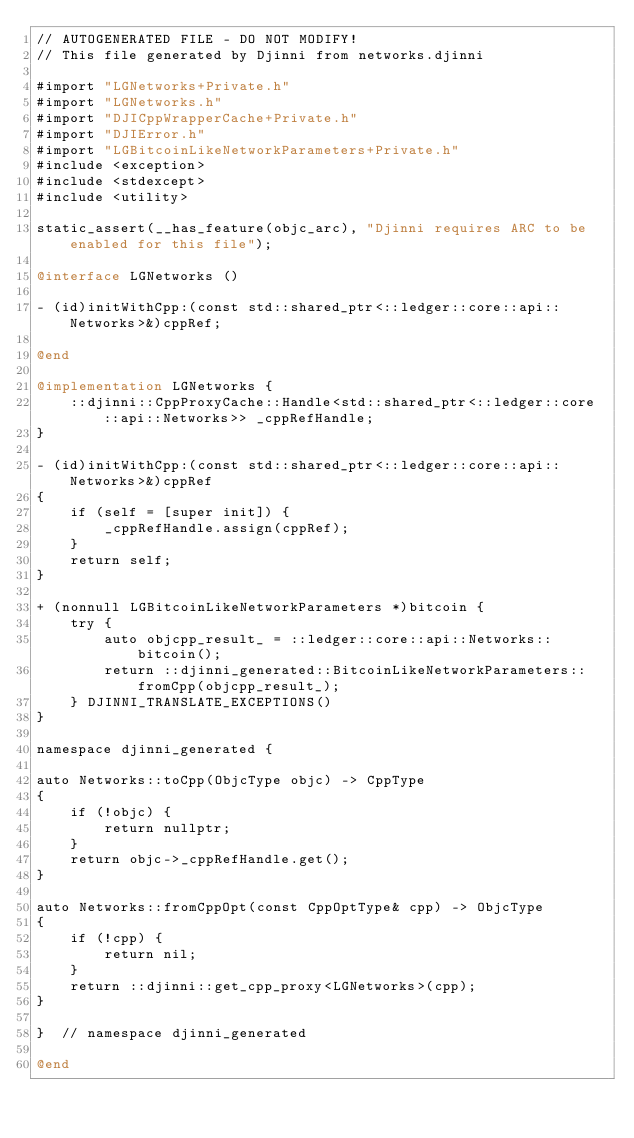<code> <loc_0><loc_0><loc_500><loc_500><_ObjectiveC_>// AUTOGENERATED FILE - DO NOT MODIFY!
// This file generated by Djinni from networks.djinni

#import "LGNetworks+Private.h"
#import "LGNetworks.h"
#import "DJICppWrapperCache+Private.h"
#import "DJIError.h"
#import "LGBitcoinLikeNetworkParameters+Private.h"
#include <exception>
#include <stdexcept>
#include <utility>

static_assert(__has_feature(objc_arc), "Djinni requires ARC to be enabled for this file");

@interface LGNetworks ()

- (id)initWithCpp:(const std::shared_ptr<::ledger::core::api::Networks>&)cppRef;

@end

@implementation LGNetworks {
    ::djinni::CppProxyCache::Handle<std::shared_ptr<::ledger::core::api::Networks>> _cppRefHandle;
}

- (id)initWithCpp:(const std::shared_ptr<::ledger::core::api::Networks>&)cppRef
{
    if (self = [super init]) {
        _cppRefHandle.assign(cppRef);
    }
    return self;
}

+ (nonnull LGBitcoinLikeNetworkParameters *)bitcoin {
    try {
        auto objcpp_result_ = ::ledger::core::api::Networks::bitcoin();
        return ::djinni_generated::BitcoinLikeNetworkParameters::fromCpp(objcpp_result_);
    } DJINNI_TRANSLATE_EXCEPTIONS()
}

namespace djinni_generated {

auto Networks::toCpp(ObjcType objc) -> CppType
{
    if (!objc) {
        return nullptr;
    }
    return objc->_cppRefHandle.get();
}

auto Networks::fromCppOpt(const CppOptType& cpp) -> ObjcType
{
    if (!cpp) {
        return nil;
    }
    return ::djinni::get_cpp_proxy<LGNetworks>(cpp);
}

}  // namespace djinni_generated

@end
</code> 